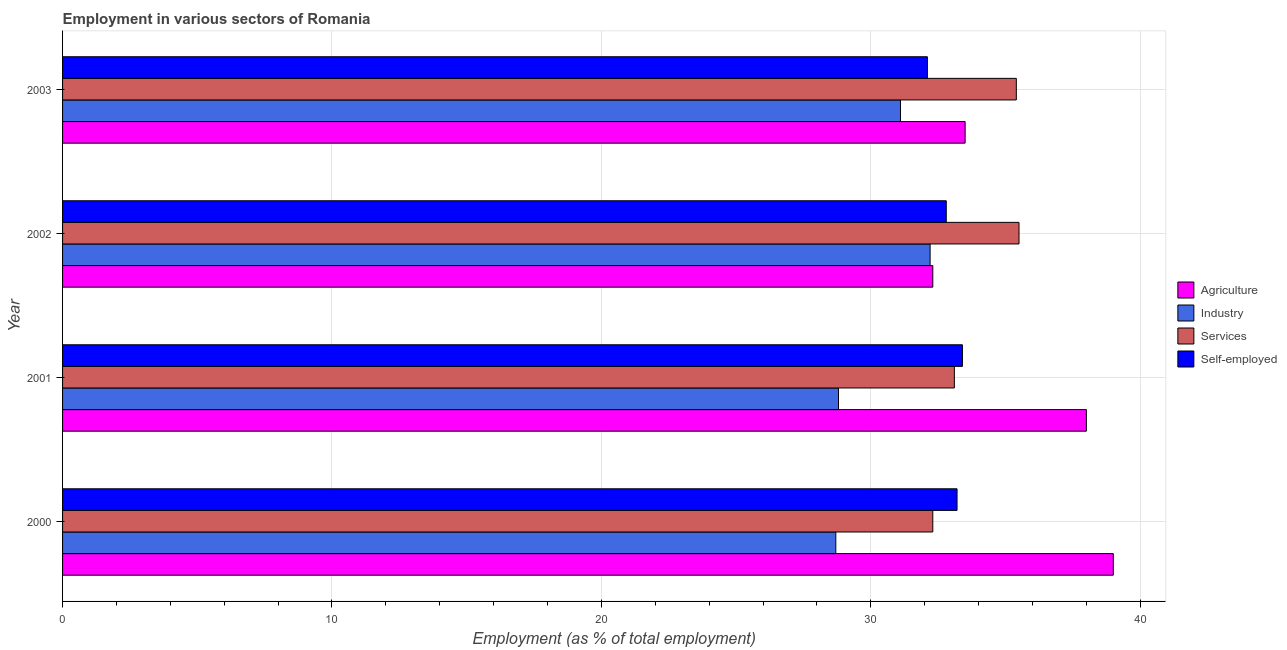How many different coloured bars are there?
Give a very brief answer. 4. How many groups of bars are there?
Ensure brevity in your answer.  4. Are the number of bars per tick equal to the number of legend labels?
Provide a short and direct response. Yes. Are the number of bars on each tick of the Y-axis equal?
Ensure brevity in your answer.  Yes. What is the label of the 1st group of bars from the top?
Make the answer very short. 2003. What is the percentage of workers in industry in 2001?
Offer a very short reply. 28.8. Across all years, what is the minimum percentage of workers in services?
Provide a succinct answer. 32.3. In which year was the percentage of workers in services maximum?
Ensure brevity in your answer.  2002. What is the total percentage of workers in services in the graph?
Offer a very short reply. 136.3. What is the difference between the percentage of self employed workers in 2001 and that in 2002?
Make the answer very short. 0.6. What is the difference between the percentage of workers in agriculture in 2002 and the percentage of workers in services in 2001?
Ensure brevity in your answer.  -0.8. What is the average percentage of workers in agriculture per year?
Your answer should be very brief. 35.7. What is the ratio of the percentage of workers in services in 2000 to that in 2002?
Your answer should be very brief. 0.91. Is the percentage of workers in services in 2000 less than that in 2002?
Your answer should be compact. Yes. In how many years, is the percentage of workers in agriculture greater than the average percentage of workers in agriculture taken over all years?
Offer a very short reply. 2. What does the 4th bar from the top in 2000 represents?
Your answer should be very brief. Agriculture. What does the 3rd bar from the bottom in 2001 represents?
Give a very brief answer. Services. Is it the case that in every year, the sum of the percentage of workers in agriculture and percentage of workers in industry is greater than the percentage of workers in services?
Your answer should be compact. Yes. How many bars are there?
Give a very brief answer. 16. Are all the bars in the graph horizontal?
Provide a short and direct response. Yes. What is the difference between two consecutive major ticks on the X-axis?
Your answer should be very brief. 10. Does the graph contain any zero values?
Provide a short and direct response. No. Where does the legend appear in the graph?
Your answer should be compact. Center right. How many legend labels are there?
Keep it short and to the point. 4. How are the legend labels stacked?
Offer a terse response. Vertical. What is the title of the graph?
Offer a terse response. Employment in various sectors of Romania. What is the label or title of the X-axis?
Your response must be concise. Employment (as % of total employment). What is the Employment (as % of total employment) of Industry in 2000?
Offer a terse response. 28.7. What is the Employment (as % of total employment) in Services in 2000?
Provide a succinct answer. 32.3. What is the Employment (as % of total employment) in Self-employed in 2000?
Your answer should be compact. 33.2. What is the Employment (as % of total employment) of Industry in 2001?
Keep it short and to the point. 28.8. What is the Employment (as % of total employment) of Services in 2001?
Offer a terse response. 33.1. What is the Employment (as % of total employment) in Self-employed in 2001?
Provide a short and direct response. 33.4. What is the Employment (as % of total employment) in Agriculture in 2002?
Provide a succinct answer. 32.3. What is the Employment (as % of total employment) in Industry in 2002?
Your response must be concise. 32.2. What is the Employment (as % of total employment) of Services in 2002?
Your response must be concise. 35.5. What is the Employment (as % of total employment) in Self-employed in 2002?
Ensure brevity in your answer.  32.8. What is the Employment (as % of total employment) of Agriculture in 2003?
Your answer should be compact. 33.5. What is the Employment (as % of total employment) of Industry in 2003?
Provide a succinct answer. 31.1. What is the Employment (as % of total employment) of Services in 2003?
Your answer should be very brief. 35.4. What is the Employment (as % of total employment) of Self-employed in 2003?
Offer a terse response. 32.1. Across all years, what is the maximum Employment (as % of total employment) in Agriculture?
Make the answer very short. 39. Across all years, what is the maximum Employment (as % of total employment) of Industry?
Give a very brief answer. 32.2. Across all years, what is the maximum Employment (as % of total employment) of Services?
Offer a very short reply. 35.5. Across all years, what is the maximum Employment (as % of total employment) in Self-employed?
Your response must be concise. 33.4. Across all years, what is the minimum Employment (as % of total employment) of Agriculture?
Your response must be concise. 32.3. Across all years, what is the minimum Employment (as % of total employment) of Industry?
Your answer should be very brief. 28.7. Across all years, what is the minimum Employment (as % of total employment) of Services?
Provide a succinct answer. 32.3. Across all years, what is the minimum Employment (as % of total employment) in Self-employed?
Your response must be concise. 32.1. What is the total Employment (as % of total employment) in Agriculture in the graph?
Your answer should be compact. 142.8. What is the total Employment (as % of total employment) of Industry in the graph?
Your answer should be compact. 120.8. What is the total Employment (as % of total employment) of Services in the graph?
Give a very brief answer. 136.3. What is the total Employment (as % of total employment) of Self-employed in the graph?
Provide a short and direct response. 131.5. What is the difference between the Employment (as % of total employment) in Agriculture in 2000 and that in 2001?
Your response must be concise. 1. What is the difference between the Employment (as % of total employment) of Industry in 2000 and that in 2001?
Give a very brief answer. -0.1. What is the difference between the Employment (as % of total employment) of Self-employed in 2000 and that in 2002?
Your answer should be compact. 0.4. What is the difference between the Employment (as % of total employment) of Agriculture in 2000 and that in 2003?
Your response must be concise. 5.5. What is the difference between the Employment (as % of total employment) in Self-employed in 2000 and that in 2003?
Offer a terse response. 1.1. What is the difference between the Employment (as % of total employment) in Industry in 2001 and that in 2002?
Your answer should be compact. -3.4. What is the difference between the Employment (as % of total employment) of Agriculture in 2001 and that in 2003?
Provide a succinct answer. 4.5. What is the difference between the Employment (as % of total employment) of Industry in 2001 and that in 2003?
Provide a short and direct response. -2.3. What is the difference between the Employment (as % of total employment) in Agriculture in 2002 and that in 2003?
Make the answer very short. -1.2. What is the difference between the Employment (as % of total employment) in Industry in 2002 and that in 2003?
Your answer should be very brief. 1.1. What is the difference between the Employment (as % of total employment) of Agriculture in 2000 and the Employment (as % of total employment) of Industry in 2001?
Offer a terse response. 10.2. What is the difference between the Employment (as % of total employment) in Agriculture in 2000 and the Employment (as % of total employment) in Self-employed in 2001?
Ensure brevity in your answer.  5.6. What is the difference between the Employment (as % of total employment) of Industry in 2000 and the Employment (as % of total employment) of Services in 2001?
Give a very brief answer. -4.4. What is the difference between the Employment (as % of total employment) of Agriculture in 2000 and the Employment (as % of total employment) of Services in 2002?
Offer a very short reply. 3.5. What is the difference between the Employment (as % of total employment) of Agriculture in 2000 and the Employment (as % of total employment) of Industry in 2003?
Your answer should be compact. 7.9. What is the difference between the Employment (as % of total employment) of Agriculture in 2000 and the Employment (as % of total employment) of Self-employed in 2003?
Offer a very short reply. 6.9. What is the difference between the Employment (as % of total employment) of Industry in 2000 and the Employment (as % of total employment) of Services in 2003?
Your answer should be very brief. -6.7. What is the difference between the Employment (as % of total employment) in Industry in 2000 and the Employment (as % of total employment) in Self-employed in 2003?
Offer a terse response. -3.4. What is the difference between the Employment (as % of total employment) of Services in 2000 and the Employment (as % of total employment) of Self-employed in 2003?
Your answer should be compact. 0.2. What is the difference between the Employment (as % of total employment) in Agriculture in 2001 and the Employment (as % of total employment) in Services in 2002?
Provide a short and direct response. 2.5. What is the difference between the Employment (as % of total employment) of Agriculture in 2001 and the Employment (as % of total employment) of Self-employed in 2002?
Keep it short and to the point. 5.2. What is the difference between the Employment (as % of total employment) in Industry in 2001 and the Employment (as % of total employment) in Self-employed in 2002?
Your answer should be very brief. -4. What is the difference between the Employment (as % of total employment) in Services in 2001 and the Employment (as % of total employment) in Self-employed in 2002?
Give a very brief answer. 0.3. What is the difference between the Employment (as % of total employment) in Services in 2001 and the Employment (as % of total employment) in Self-employed in 2003?
Your answer should be very brief. 1. What is the difference between the Employment (as % of total employment) in Agriculture in 2002 and the Employment (as % of total employment) in Services in 2003?
Your answer should be compact. -3.1. What is the difference between the Employment (as % of total employment) in Agriculture in 2002 and the Employment (as % of total employment) in Self-employed in 2003?
Offer a terse response. 0.2. What is the difference between the Employment (as % of total employment) of Industry in 2002 and the Employment (as % of total employment) of Self-employed in 2003?
Offer a terse response. 0.1. What is the difference between the Employment (as % of total employment) in Services in 2002 and the Employment (as % of total employment) in Self-employed in 2003?
Provide a succinct answer. 3.4. What is the average Employment (as % of total employment) of Agriculture per year?
Offer a terse response. 35.7. What is the average Employment (as % of total employment) in Industry per year?
Offer a very short reply. 30.2. What is the average Employment (as % of total employment) in Services per year?
Your response must be concise. 34.08. What is the average Employment (as % of total employment) in Self-employed per year?
Your answer should be compact. 32.88. In the year 2000, what is the difference between the Employment (as % of total employment) of Agriculture and Employment (as % of total employment) of Services?
Your answer should be very brief. 6.7. In the year 2000, what is the difference between the Employment (as % of total employment) of Agriculture and Employment (as % of total employment) of Self-employed?
Provide a succinct answer. 5.8. In the year 2000, what is the difference between the Employment (as % of total employment) of Industry and Employment (as % of total employment) of Services?
Give a very brief answer. -3.6. In the year 2000, what is the difference between the Employment (as % of total employment) in Services and Employment (as % of total employment) in Self-employed?
Ensure brevity in your answer.  -0.9. In the year 2001, what is the difference between the Employment (as % of total employment) of Agriculture and Employment (as % of total employment) of Services?
Your answer should be very brief. 4.9. In the year 2001, what is the difference between the Employment (as % of total employment) in Agriculture and Employment (as % of total employment) in Self-employed?
Provide a succinct answer. 4.6. In the year 2002, what is the difference between the Employment (as % of total employment) in Agriculture and Employment (as % of total employment) in Services?
Your answer should be compact. -3.2. In the year 2002, what is the difference between the Employment (as % of total employment) of Agriculture and Employment (as % of total employment) of Self-employed?
Your answer should be compact. -0.5. In the year 2002, what is the difference between the Employment (as % of total employment) in Industry and Employment (as % of total employment) in Services?
Ensure brevity in your answer.  -3.3. In the year 2002, what is the difference between the Employment (as % of total employment) of Industry and Employment (as % of total employment) of Self-employed?
Make the answer very short. -0.6. In the year 2003, what is the difference between the Employment (as % of total employment) of Agriculture and Employment (as % of total employment) of Industry?
Offer a terse response. 2.4. In the year 2003, what is the difference between the Employment (as % of total employment) in Agriculture and Employment (as % of total employment) in Services?
Keep it short and to the point. -1.9. In the year 2003, what is the difference between the Employment (as % of total employment) of Agriculture and Employment (as % of total employment) of Self-employed?
Your answer should be very brief. 1.4. In the year 2003, what is the difference between the Employment (as % of total employment) in Industry and Employment (as % of total employment) in Self-employed?
Offer a terse response. -1. In the year 2003, what is the difference between the Employment (as % of total employment) in Services and Employment (as % of total employment) in Self-employed?
Your answer should be very brief. 3.3. What is the ratio of the Employment (as % of total employment) of Agriculture in 2000 to that in 2001?
Ensure brevity in your answer.  1.03. What is the ratio of the Employment (as % of total employment) in Industry in 2000 to that in 2001?
Give a very brief answer. 1. What is the ratio of the Employment (as % of total employment) of Services in 2000 to that in 2001?
Offer a terse response. 0.98. What is the ratio of the Employment (as % of total employment) in Self-employed in 2000 to that in 2001?
Your answer should be very brief. 0.99. What is the ratio of the Employment (as % of total employment) in Agriculture in 2000 to that in 2002?
Your response must be concise. 1.21. What is the ratio of the Employment (as % of total employment) in Industry in 2000 to that in 2002?
Your response must be concise. 0.89. What is the ratio of the Employment (as % of total employment) in Services in 2000 to that in 2002?
Keep it short and to the point. 0.91. What is the ratio of the Employment (as % of total employment) in Self-employed in 2000 to that in 2002?
Your response must be concise. 1.01. What is the ratio of the Employment (as % of total employment) in Agriculture in 2000 to that in 2003?
Make the answer very short. 1.16. What is the ratio of the Employment (as % of total employment) of Industry in 2000 to that in 2003?
Your response must be concise. 0.92. What is the ratio of the Employment (as % of total employment) of Services in 2000 to that in 2003?
Keep it short and to the point. 0.91. What is the ratio of the Employment (as % of total employment) of Self-employed in 2000 to that in 2003?
Your answer should be very brief. 1.03. What is the ratio of the Employment (as % of total employment) of Agriculture in 2001 to that in 2002?
Your answer should be compact. 1.18. What is the ratio of the Employment (as % of total employment) in Industry in 2001 to that in 2002?
Offer a terse response. 0.89. What is the ratio of the Employment (as % of total employment) in Services in 2001 to that in 2002?
Give a very brief answer. 0.93. What is the ratio of the Employment (as % of total employment) in Self-employed in 2001 to that in 2002?
Your response must be concise. 1.02. What is the ratio of the Employment (as % of total employment) in Agriculture in 2001 to that in 2003?
Offer a very short reply. 1.13. What is the ratio of the Employment (as % of total employment) in Industry in 2001 to that in 2003?
Offer a terse response. 0.93. What is the ratio of the Employment (as % of total employment) in Services in 2001 to that in 2003?
Keep it short and to the point. 0.94. What is the ratio of the Employment (as % of total employment) in Self-employed in 2001 to that in 2003?
Your response must be concise. 1.04. What is the ratio of the Employment (as % of total employment) in Agriculture in 2002 to that in 2003?
Provide a short and direct response. 0.96. What is the ratio of the Employment (as % of total employment) of Industry in 2002 to that in 2003?
Your answer should be compact. 1.04. What is the ratio of the Employment (as % of total employment) in Services in 2002 to that in 2003?
Offer a terse response. 1. What is the ratio of the Employment (as % of total employment) of Self-employed in 2002 to that in 2003?
Ensure brevity in your answer.  1.02. What is the difference between the highest and the second highest Employment (as % of total employment) of Agriculture?
Keep it short and to the point. 1. What is the difference between the highest and the second highest Employment (as % of total employment) in Services?
Keep it short and to the point. 0.1. What is the difference between the highest and the second highest Employment (as % of total employment) in Self-employed?
Your response must be concise. 0.2. What is the difference between the highest and the lowest Employment (as % of total employment) of Agriculture?
Give a very brief answer. 6.7. What is the difference between the highest and the lowest Employment (as % of total employment) in Self-employed?
Your response must be concise. 1.3. 